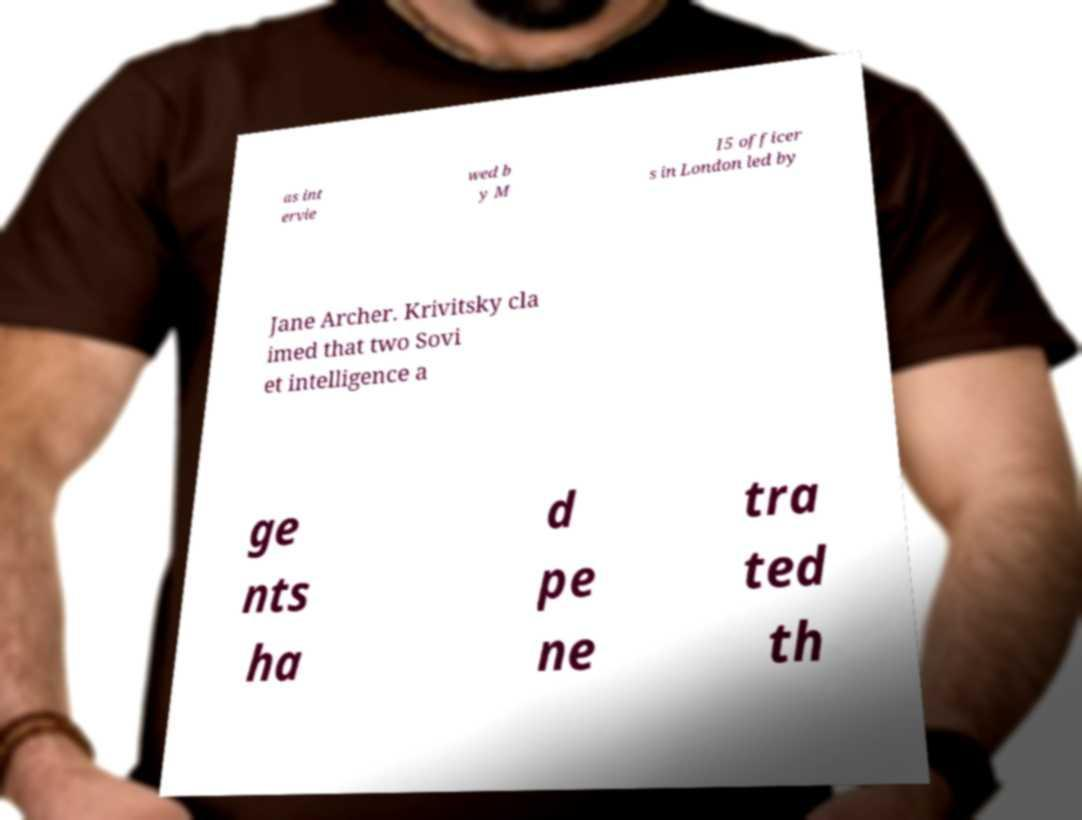Please read and relay the text visible in this image. What does it say? as int ervie wed b y M I5 officer s in London led by Jane Archer. Krivitsky cla imed that two Sovi et intelligence a ge nts ha d pe ne tra ted th 